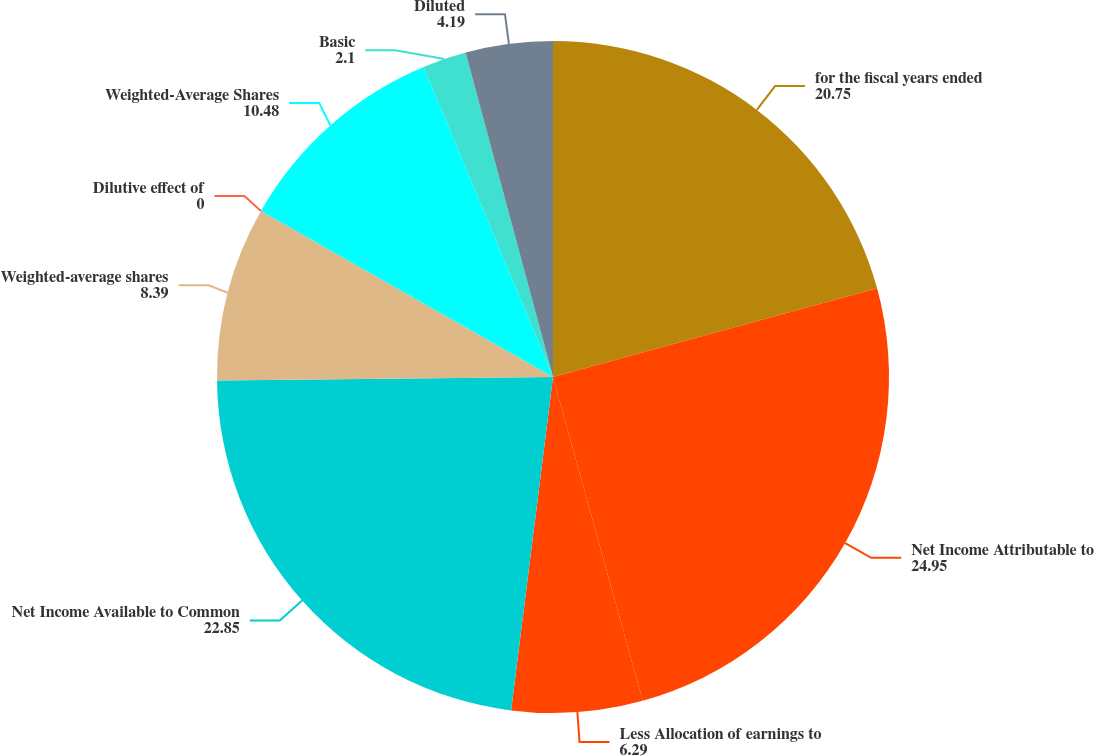<chart> <loc_0><loc_0><loc_500><loc_500><pie_chart><fcel>for the fiscal years ended<fcel>Net Income Attributable to<fcel>Less Allocation of earnings to<fcel>Net Income Available to Common<fcel>Weighted-average shares<fcel>Dilutive effect of<fcel>Weighted-Average Shares<fcel>Basic<fcel>Diluted<nl><fcel>20.75%<fcel>24.95%<fcel>6.29%<fcel>22.85%<fcel>8.39%<fcel>0.0%<fcel>10.48%<fcel>2.1%<fcel>4.19%<nl></chart> 